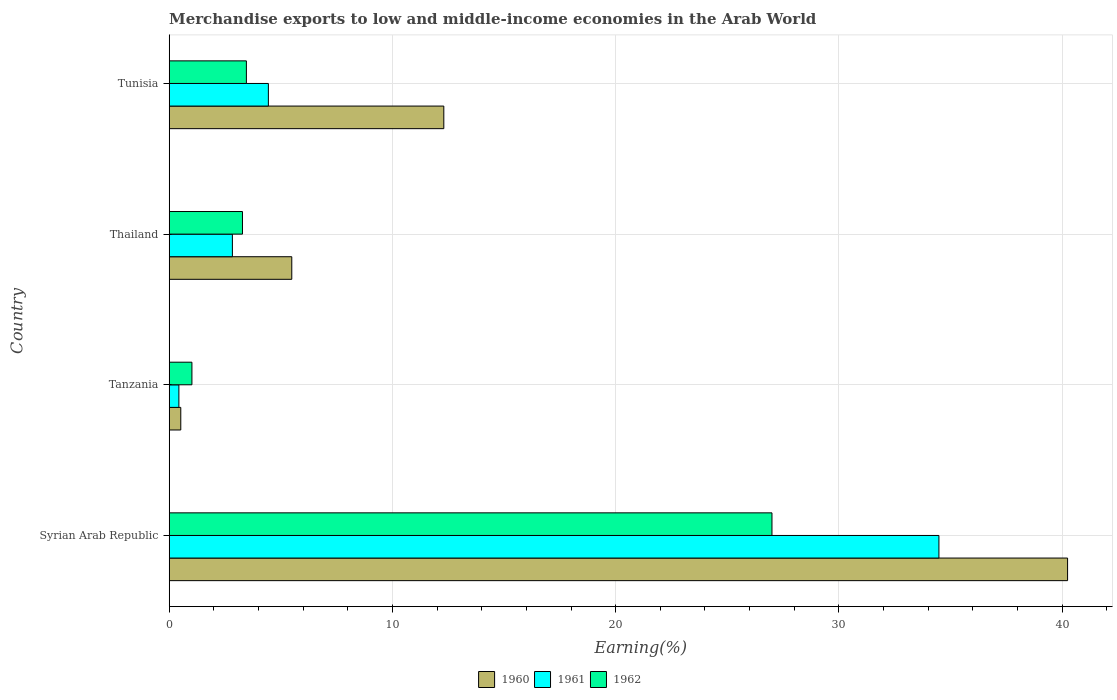How many different coloured bars are there?
Your answer should be very brief. 3. Are the number of bars per tick equal to the number of legend labels?
Your response must be concise. Yes. Are the number of bars on each tick of the Y-axis equal?
Give a very brief answer. Yes. How many bars are there on the 2nd tick from the top?
Your response must be concise. 3. How many bars are there on the 1st tick from the bottom?
Offer a terse response. 3. What is the label of the 3rd group of bars from the top?
Make the answer very short. Tanzania. In how many cases, is the number of bars for a given country not equal to the number of legend labels?
Ensure brevity in your answer.  0. What is the percentage of amount earned from merchandise exports in 1961 in Tanzania?
Your answer should be very brief. 0.43. Across all countries, what is the maximum percentage of amount earned from merchandise exports in 1960?
Offer a terse response. 40.24. Across all countries, what is the minimum percentage of amount earned from merchandise exports in 1960?
Offer a very short reply. 0.52. In which country was the percentage of amount earned from merchandise exports in 1962 maximum?
Ensure brevity in your answer.  Syrian Arab Republic. In which country was the percentage of amount earned from merchandise exports in 1962 minimum?
Offer a very short reply. Tanzania. What is the total percentage of amount earned from merchandise exports in 1960 in the graph?
Provide a short and direct response. 58.55. What is the difference between the percentage of amount earned from merchandise exports in 1960 in Tanzania and that in Thailand?
Give a very brief answer. -4.97. What is the difference between the percentage of amount earned from merchandise exports in 1960 in Thailand and the percentage of amount earned from merchandise exports in 1962 in Syrian Arab Republic?
Make the answer very short. -21.51. What is the average percentage of amount earned from merchandise exports in 1962 per country?
Keep it short and to the point. 8.69. What is the difference between the percentage of amount earned from merchandise exports in 1961 and percentage of amount earned from merchandise exports in 1960 in Tanzania?
Offer a very short reply. -0.08. In how many countries, is the percentage of amount earned from merchandise exports in 1961 greater than 38 %?
Ensure brevity in your answer.  0. What is the ratio of the percentage of amount earned from merchandise exports in 1961 in Syrian Arab Republic to that in Tunisia?
Provide a succinct answer. 7.76. Is the percentage of amount earned from merchandise exports in 1962 in Syrian Arab Republic less than that in Tunisia?
Your answer should be compact. No. What is the difference between the highest and the second highest percentage of amount earned from merchandise exports in 1961?
Offer a very short reply. 30.04. What is the difference between the highest and the lowest percentage of amount earned from merchandise exports in 1960?
Your answer should be very brief. 39.72. In how many countries, is the percentage of amount earned from merchandise exports in 1961 greater than the average percentage of amount earned from merchandise exports in 1961 taken over all countries?
Your answer should be very brief. 1. Is the sum of the percentage of amount earned from merchandise exports in 1962 in Syrian Arab Republic and Tunisia greater than the maximum percentage of amount earned from merchandise exports in 1960 across all countries?
Provide a succinct answer. No. What does the 2nd bar from the top in Tanzania represents?
Provide a succinct answer. 1961. Is it the case that in every country, the sum of the percentage of amount earned from merchandise exports in 1961 and percentage of amount earned from merchandise exports in 1960 is greater than the percentage of amount earned from merchandise exports in 1962?
Ensure brevity in your answer.  No. How many countries are there in the graph?
Make the answer very short. 4. Does the graph contain grids?
Offer a very short reply. Yes. Where does the legend appear in the graph?
Keep it short and to the point. Bottom center. How many legend labels are there?
Make the answer very short. 3. What is the title of the graph?
Your answer should be compact. Merchandise exports to low and middle-income economies in the Arab World. What is the label or title of the X-axis?
Your answer should be compact. Earning(%). What is the Earning(%) in 1960 in Syrian Arab Republic?
Provide a short and direct response. 40.24. What is the Earning(%) of 1961 in Syrian Arab Republic?
Offer a terse response. 34.48. What is the Earning(%) of 1962 in Syrian Arab Republic?
Ensure brevity in your answer.  27. What is the Earning(%) of 1960 in Tanzania?
Provide a succinct answer. 0.52. What is the Earning(%) in 1961 in Tanzania?
Ensure brevity in your answer.  0.43. What is the Earning(%) in 1962 in Tanzania?
Your answer should be very brief. 1.02. What is the Earning(%) in 1960 in Thailand?
Ensure brevity in your answer.  5.49. What is the Earning(%) in 1961 in Thailand?
Keep it short and to the point. 2.83. What is the Earning(%) of 1962 in Thailand?
Provide a short and direct response. 3.28. What is the Earning(%) in 1960 in Tunisia?
Ensure brevity in your answer.  12.3. What is the Earning(%) of 1961 in Tunisia?
Offer a terse response. 4.44. What is the Earning(%) in 1962 in Tunisia?
Keep it short and to the point. 3.46. Across all countries, what is the maximum Earning(%) of 1960?
Provide a succinct answer. 40.24. Across all countries, what is the maximum Earning(%) of 1961?
Give a very brief answer. 34.48. Across all countries, what is the maximum Earning(%) of 1962?
Offer a terse response. 27. Across all countries, what is the minimum Earning(%) of 1960?
Offer a terse response. 0.52. Across all countries, what is the minimum Earning(%) in 1961?
Make the answer very short. 0.43. Across all countries, what is the minimum Earning(%) in 1962?
Offer a very short reply. 1.02. What is the total Earning(%) of 1960 in the graph?
Keep it short and to the point. 58.55. What is the total Earning(%) of 1961 in the graph?
Keep it short and to the point. 42.19. What is the total Earning(%) in 1962 in the graph?
Offer a very short reply. 34.76. What is the difference between the Earning(%) in 1960 in Syrian Arab Republic and that in Tanzania?
Offer a very short reply. 39.72. What is the difference between the Earning(%) of 1961 in Syrian Arab Republic and that in Tanzania?
Offer a very short reply. 34.05. What is the difference between the Earning(%) in 1962 in Syrian Arab Republic and that in Tanzania?
Give a very brief answer. 25.98. What is the difference between the Earning(%) of 1960 in Syrian Arab Republic and that in Thailand?
Provide a succinct answer. 34.75. What is the difference between the Earning(%) in 1961 in Syrian Arab Republic and that in Thailand?
Your response must be concise. 31.65. What is the difference between the Earning(%) of 1962 in Syrian Arab Republic and that in Thailand?
Your response must be concise. 23.72. What is the difference between the Earning(%) of 1960 in Syrian Arab Republic and that in Tunisia?
Your response must be concise. 27.94. What is the difference between the Earning(%) in 1961 in Syrian Arab Republic and that in Tunisia?
Offer a terse response. 30.04. What is the difference between the Earning(%) in 1962 in Syrian Arab Republic and that in Tunisia?
Provide a short and direct response. 23.54. What is the difference between the Earning(%) of 1960 in Tanzania and that in Thailand?
Give a very brief answer. -4.97. What is the difference between the Earning(%) in 1961 in Tanzania and that in Thailand?
Give a very brief answer. -2.4. What is the difference between the Earning(%) of 1962 in Tanzania and that in Thailand?
Keep it short and to the point. -2.26. What is the difference between the Earning(%) of 1960 in Tanzania and that in Tunisia?
Your answer should be very brief. -11.78. What is the difference between the Earning(%) in 1961 in Tanzania and that in Tunisia?
Your answer should be very brief. -4.01. What is the difference between the Earning(%) in 1962 in Tanzania and that in Tunisia?
Provide a succinct answer. -2.44. What is the difference between the Earning(%) in 1960 in Thailand and that in Tunisia?
Your answer should be compact. -6.81. What is the difference between the Earning(%) in 1961 in Thailand and that in Tunisia?
Your answer should be very brief. -1.61. What is the difference between the Earning(%) of 1962 in Thailand and that in Tunisia?
Provide a short and direct response. -0.18. What is the difference between the Earning(%) of 1960 in Syrian Arab Republic and the Earning(%) of 1961 in Tanzania?
Your answer should be very brief. 39.81. What is the difference between the Earning(%) in 1960 in Syrian Arab Republic and the Earning(%) in 1962 in Tanzania?
Ensure brevity in your answer.  39.23. What is the difference between the Earning(%) in 1961 in Syrian Arab Republic and the Earning(%) in 1962 in Tanzania?
Keep it short and to the point. 33.46. What is the difference between the Earning(%) in 1960 in Syrian Arab Republic and the Earning(%) in 1961 in Thailand?
Your answer should be compact. 37.41. What is the difference between the Earning(%) of 1960 in Syrian Arab Republic and the Earning(%) of 1962 in Thailand?
Your answer should be compact. 36.96. What is the difference between the Earning(%) of 1961 in Syrian Arab Republic and the Earning(%) of 1962 in Thailand?
Provide a succinct answer. 31.2. What is the difference between the Earning(%) of 1960 in Syrian Arab Republic and the Earning(%) of 1961 in Tunisia?
Provide a succinct answer. 35.8. What is the difference between the Earning(%) of 1960 in Syrian Arab Republic and the Earning(%) of 1962 in Tunisia?
Keep it short and to the point. 36.79. What is the difference between the Earning(%) of 1961 in Syrian Arab Republic and the Earning(%) of 1962 in Tunisia?
Your answer should be compact. 31.02. What is the difference between the Earning(%) of 1960 in Tanzania and the Earning(%) of 1961 in Thailand?
Keep it short and to the point. -2.31. What is the difference between the Earning(%) of 1960 in Tanzania and the Earning(%) of 1962 in Thailand?
Ensure brevity in your answer.  -2.76. What is the difference between the Earning(%) of 1961 in Tanzania and the Earning(%) of 1962 in Thailand?
Provide a short and direct response. -2.85. What is the difference between the Earning(%) of 1960 in Tanzania and the Earning(%) of 1961 in Tunisia?
Your answer should be very brief. -3.92. What is the difference between the Earning(%) of 1960 in Tanzania and the Earning(%) of 1962 in Tunisia?
Offer a terse response. -2.94. What is the difference between the Earning(%) in 1961 in Tanzania and the Earning(%) in 1962 in Tunisia?
Your response must be concise. -3.02. What is the difference between the Earning(%) of 1960 in Thailand and the Earning(%) of 1961 in Tunisia?
Keep it short and to the point. 1.05. What is the difference between the Earning(%) of 1960 in Thailand and the Earning(%) of 1962 in Tunisia?
Provide a succinct answer. 2.03. What is the difference between the Earning(%) of 1961 in Thailand and the Earning(%) of 1962 in Tunisia?
Keep it short and to the point. -0.63. What is the average Earning(%) of 1960 per country?
Your response must be concise. 14.64. What is the average Earning(%) of 1961 per country?
Offer a very short reply. 10.55. What is the average Earning(%) in 1962 per country?
Offer a very short reply. 8.69. What is the difference between the Earning(%) of 1960 and Earning(%) of 1961 in Syrian Arab Republic?
Provide a short and direct response. 5.76. What is the difference between the Earning(%) in 1960 and Earning(%) in 1962 in Syrian Arab Republic?
Your response must be concise. 13.24. What is the difference between the Earning(%) in 1961 and Earning(%) in 1962 in Syrian Arab Republic?
Give a very brief answer. 7.48. What is the difference between the Earning(%) of 1960 and Earning(%) of 1961 in Tanzania?
Your answer should be compact. 0.08. What is the difference between the Earning(%) of 1960 and Earning(%) of 1962 in Tanzania?
Provide a succinct answer. -0.5. What is the difference between the Earning(%) of 1961 and Earning(%) of 1962 in Tanzania?
Offer a very short reply. -0.58. What is the difference between the Earning(%) in 1960 and Earning(%) in 1961 in Thailand?
Your response must be concise. 2.66. What is the difference between the Earning(%) in 1960 and Earning(%) in 1962 in Thailand?
Provide a succinct answer. 2.21. What is the difference between the Earning(%) of 1961 and Earning(%) of 1962 in Thailand?
Provide a short and direct response. -0.45. What is the difference between the Earning(%) of 1960 and Earning(%) of 1961 in Tunisia?
Provide a short and direct response. 7.86. What is the difference between the Earning(%) of 1960 and Earning(%) of 1962 in Tunisia?
Provide a short and direct response. 8.84. What is the difference between the Earning(%) of 1961 and Earning(%) of 1962 in Tunisia?
Provide a succinct answer. 0.99. What is the ratio of the Earning(%) in 1960 in Syrian Arab Republic to that in Tanzania?
Provide a succinct answer. 77.57. What is the ratio of the Earning(%) in 1961 in Syrian Arab Republic to that in Tanzania?
Your response must be concise. 79.42. What is the ratio of the Earning(%) of 1962 in Syrian Arab Republic to that in Tanzania?
Provide a succinct answer. 26.53. What is the ratio of the Earning(%) in 1960 in Syrian Arab Republic to that in Thailand?
Your answer should be very brief. 7.33. What is the ratio of the Earning(%) in 1961 in Syrian Arab Republic to that in Thailand?
Make the answer very short. 12.18. What is the ratio of the Earning(%) in 1962 in Syrian Arab Republic to that in Thailand?
Provide a succinct answer. 8.23. What is the ratio of the Earning(%) of 1960 in Syrian Arab Republic to that in Tunisia?
Provide a succinct answer. 3.27. What is the ratio of the Earning(%) of 1961 in Syrian Arab Republic to that in Tunisia?
Keep it short and to the point. 7.76. What is the ratio of the Earning(%) in 1962 in Syrian Arab Republic to that in Tunisia?
Offer a very short reply. 7.81. What is the ratio of the Earning(%) of 1960 in Tanzania to that in Thailand?
Your response must be concise. 0.09. What is the ratio of the Earning(%) of 1961 in Tanzania to that in Thailand?
Keep it short and to the point. 0.15. What is the ratio of the Earning(%) in 1962 in Tanzania to that in Thailand?
Your response must be concise. 0.31. What is the ratio of the Earning(%) in 1960 in Tanzania to that in Tunisia?
Provide a succinct answer. 0.04. What is the ratio of the Earning(%) in 1961 in Tanzania to that in Tunisia?
Your answer should be very brief. 0.1. What is the ratio of the Earning(%) in 1962 in Tanzania to that in Tunisia?
Your answer should be very brief. 0.29. What is the ratio of the Earning(%) in 1960 in Thailand to that in Tunisia?
Your response must be concise. 0.45. What is the ratio of the Earning(%) of 1961 in Thailand to that in Tunisia?
Provide a succinct answer. 0.64. What is the ratio of the Earning(%) in 1962 in Thailand to that in Tunisia?
Your answer should be very brief. 0.95. What is the difference between the highest and the second highest Earning(%) of 1960?
Make the answer very short. 27.94. What is the difference between the highest and the second highest Earning(%) in 1961?
Offer a very short reply. 30.04. What is the difference between the highest and the second highest Earning(%) in 1962?
Provide a succinct answer. 23.54. What is the difference between the highest and the lowest Earning(%) of 1960?
Give a very brief answer. 39.72. What is the difference between the highest and the lowest Earning(%) of 1961?
Offer a terse response. 34.05. What is the difference between the highest and the lowest Earning(%) in 1962?
Your response must be concise. 25.98. 